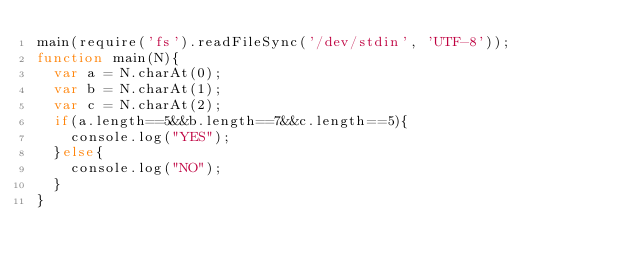<code> <loc_0><loc_0><loc_500><loc_500><_JavaScript_>main(require('fs').readFileSync('/dev/stdin', 'UTF-8'));
function main(N){
  var a = N.charAt(0);
  var b = N.charAt(1);
  var c = N.charAt(2);
  if(a.length==5&&b.length==7&&c.length==5){
    console.log("YES");
  }else{
    console.log("NO");
  }
}</code> 